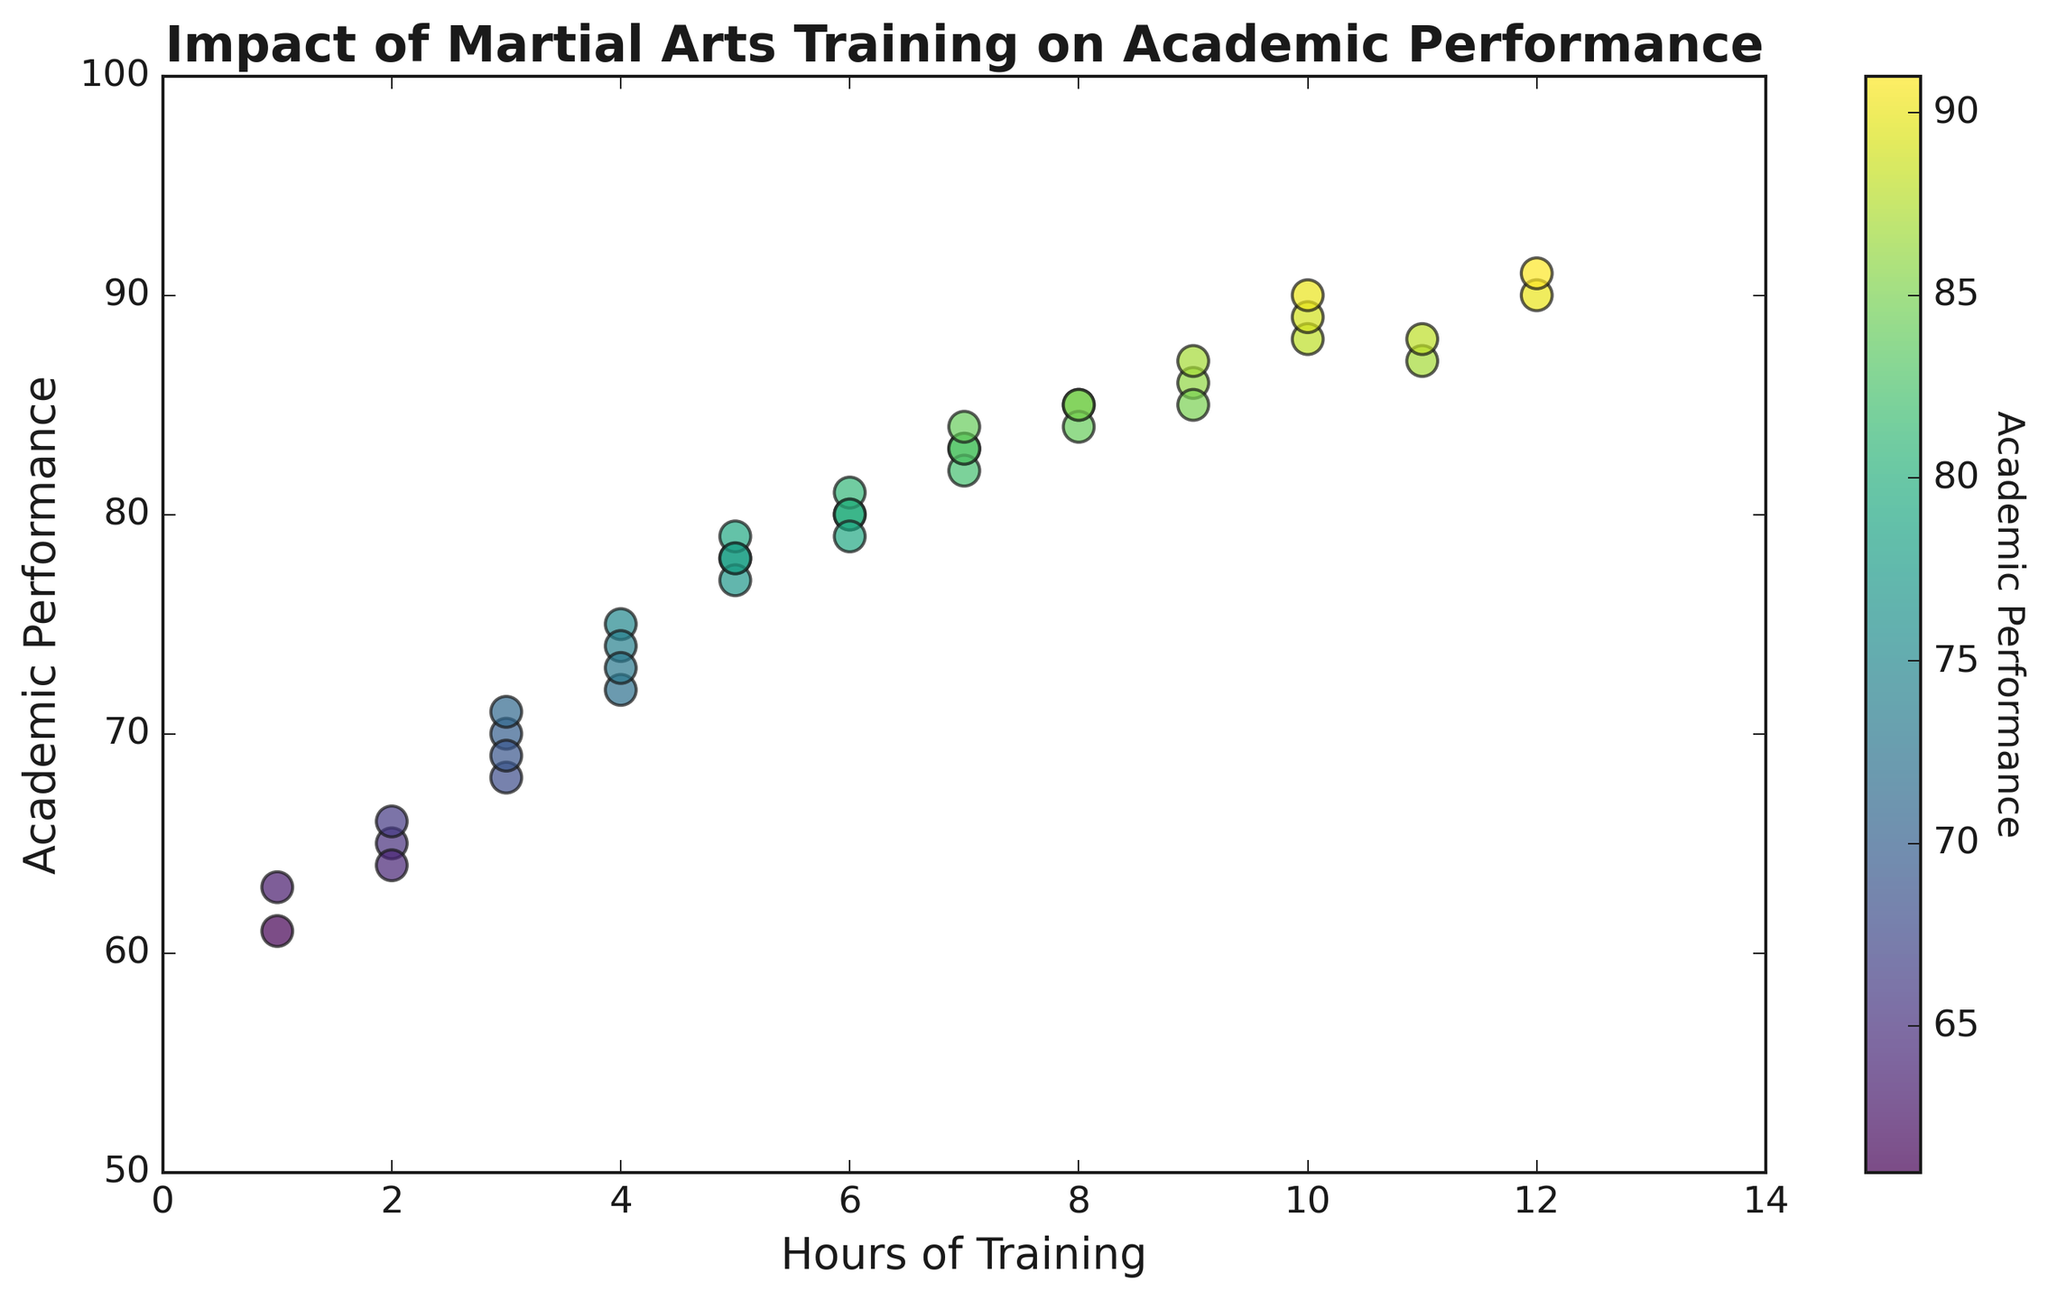What is the general trend between hours of martial arts training and academic performance among Vietnamese students? The scatter plot shows that there is a positive correlation between hours of martial arts training and academic performance. As the hours of training increase, academic performance also tends to increase.
Answer: Positive Correlation Which data point indicates the highest academic performance? The scatter plot indicates that the highest academic performance is at approximately 91, which corresponds to 12 hours of training.
Answer: 12 hours of training Are there any data points with the same hours of training but different academic performance? Yes, for example, there are two data points with 7 hours of training, and their academic performances are 83 and 84, respectively.
Answer: Yes Which data point has the lowest academic performance? The scatter plot indicates that the lowest academic performance score is around 61, which corresponds to 1 hour of training.
Answer: 1 hour of training What are the minimum and maximum academic performances observed in the figure? The minimum academic performance observed is approximately 61, while the maximum is around 91.
Answer: 61, 91 How many data points have an academic performance greater than 80? From the plot, count the number of data points above the 80 on the y-axis: there are 18 such points.
Answer: 18 If a student trains for 4 hours, what could be their approximate academic performance? The plot shows that for 4 hours of training, the academic performance ranges between 72 to 75, based on nearby points.
Answer: Approximately 72 to 75 Which hours of training have multiple data points clustered close to each other? Hours of training with multiple close data points include 7 and 6 hours, where there are multiple data points near each other on the academic performance axis.
Answer: 7 and 6 hours Is there a noticeable variation in academic performance for students who train for 2 hours? Yes, the scatter plot shows that students who train for 2 hours have academic performances around 64 to 66, showing little variation.
Answer: Yes, little variation Does the plot suggest that martial arts training has a linear effect on academic performance? The scatter plot suggests a generally positive trend but may not be perfectly linear as there are some variations and outliers.
Answer: Positive but not perfectly linear 